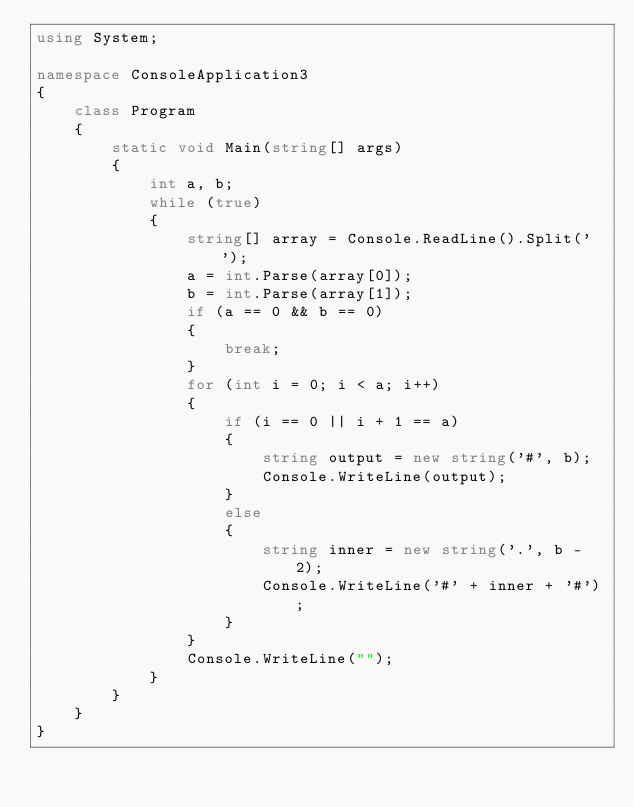<code> <loc_0><loc_0><loc_500><loc_500><_C#_>using System;

namespace ConsoleApplication3
{
    class Program
    {
        static void Main(string[] args)
        {
            int a, b;
            while (true)
            {
                string[] array = Console.ReadLine().Split(' ');
                a = int.Parse(array[0]);
                b = int.Parse(array[1]);
                if (a == 0 && b == 0)
                {
                    break;
                }
                for (int i = 0; i < a; i++)
                {
                    if (i == 0 || i + 1 == a)
                    {
                        string output = new string('#', b);
                        Console.WriteLine(output);
                    }
                    else
                    {
                        string inner = new string('.', b - 2);
                        Console.WriteLine('#' + inner + '#');
                    }
                }
                Console.WriteLine("");
            }
        }
    }
}</code> 